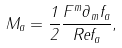Convert formula to latex. <formula><loc_0><loc_0><loc_500><loc_500>M _ { a } = \frac { 1 } { 2 } \frac { F ^ { m } \partial _ { m } f _ { a } } { R e f _ { a } } ,</formula> 